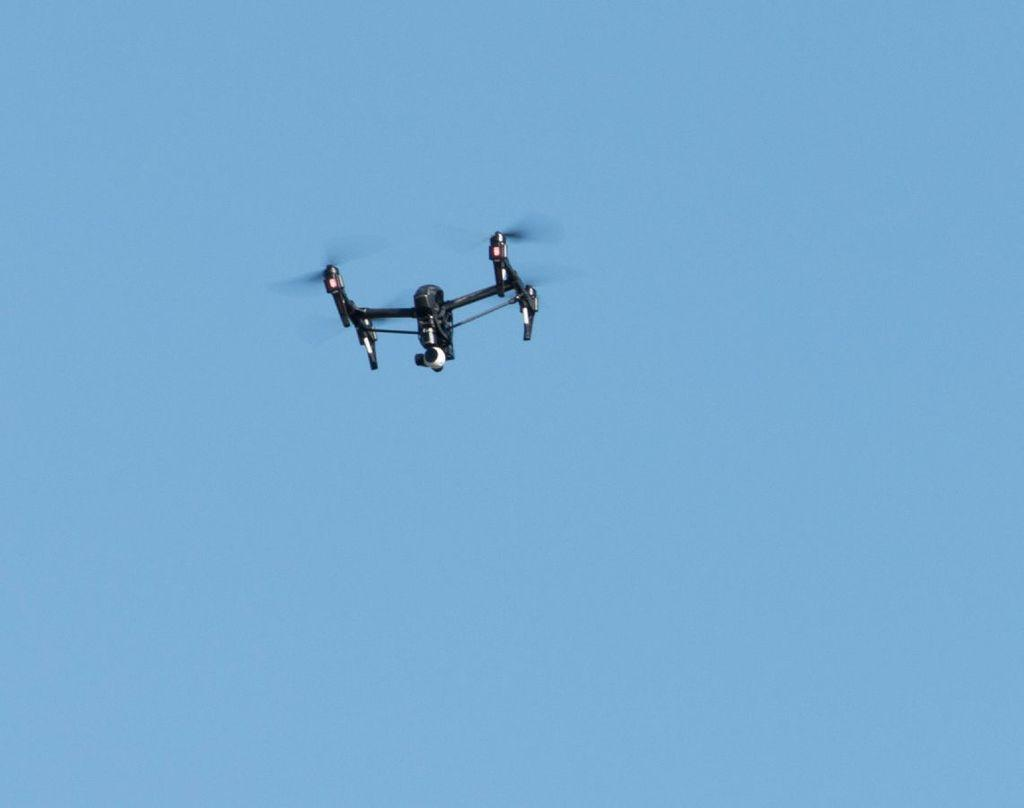What is the main subject of the image? The main subject of the image is an airplane. What can be seen in the background of the image? The sky is visible in the background of the image. Are there any children playing with their toes on the sidewalk in the image? There is no mention of children, playing, toes, or sidewalks in the image; it only features an airplane and the sky. 